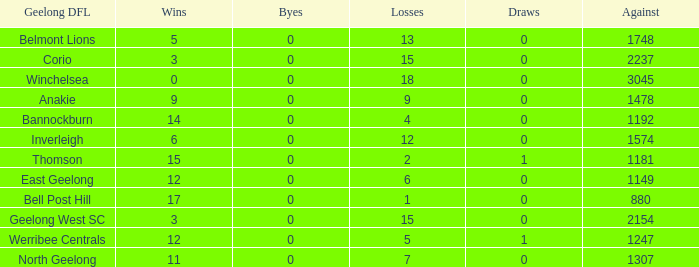What is the standard of triumphs when the byes are under 0? None. 